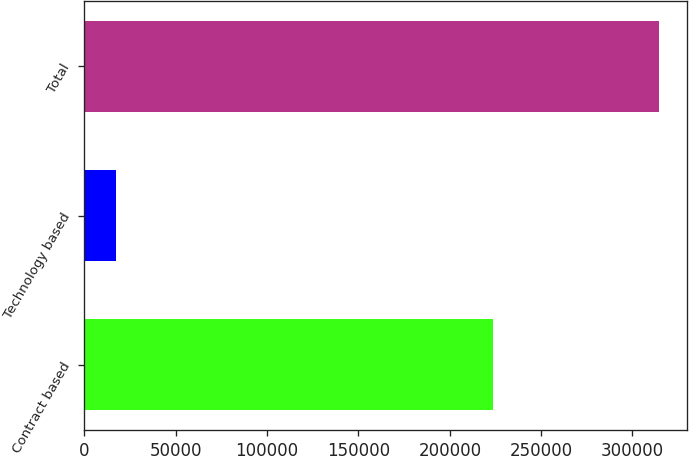Convert chart. <chart><loc_0><loc_0><loc_500><loc_500><bar_chart><fcel>Contract based<fcel>Technology based<fcel>Total<nl><fcel>223873<fcel>17181<fcel>314352<nl></chart> 